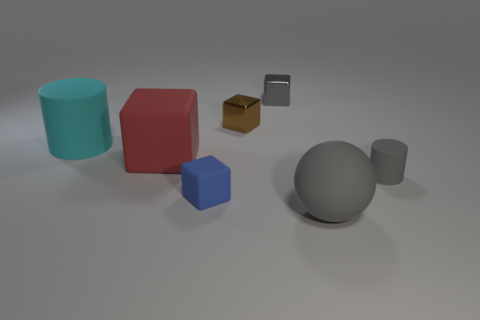Add 2 big red rubber things. How many objects exist? 9 Subtract all balls. How many objects are left? 6 Add 2 cyan metallic cylinders. How many cyan metallic cylinders exist? 2 Subtract 0 red cylinders. How many objects are left? 7 Subtract all large cyan cylinders. Subtract all large things. How many objects are left? 3 Add 5 large blocks. How many large blocks are left? 6 